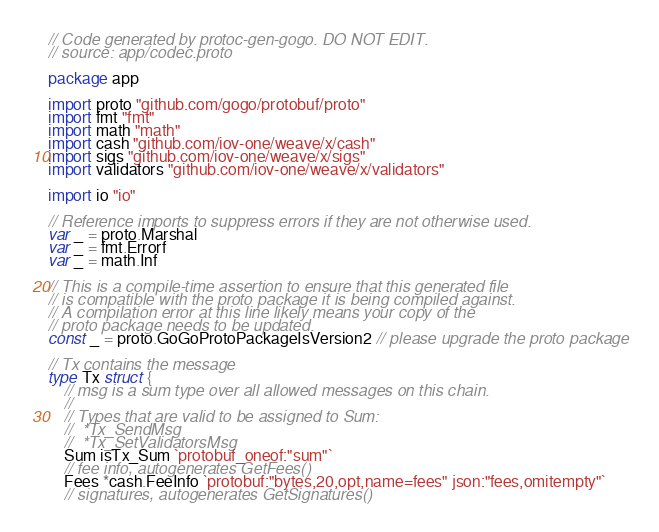Convert code to text. <code><loc_0><loc_0><loc_500><loc_500><_Go_>// Code generated by protoc-gen-gogo. DO NOT EDIT.
// source: app/codec.proto

package app

import proto "github.com/gogo/protobuf/proto"
import fmt "fmt"
import math "math"
import cash "github.com/iov-one/weave/x/cash"
import sigs "github.com/iov-one/weave/x/sigs"
import validators "github.com/iov-one/weave/x/validators"

import io "io"

// Reference imports to suppress errors if they are not otherwise used.
var _ = proto.Marshal
var _ = fmt.Errorf
var _ = math.Inf

// This is a compile-time assertion to ensure that this generated file
// is compatible with the proto package it is being compiled against.
// A compilation error at this line likely means your copy of the
// proto package needs to be updated.
const _ = proto.GoGoProtoPackageIsVersion2 // please upgrade the proto package

// Tx contains the message
type Tx struct {
	// msg is a sum type over all allowed messages on this chain.
	//
	// Types that are valid to be assigned to Sum:
	//	*Tx_SendMsg
	//	*Tx_SetValidatorsMsg
	Sum isTx_Sum `protobuf_oneof:"sum"`
	// fee info, autogenerates GetFees()
	Fees *cash.FeeInfo `protobuf:"bytes,20,opt,name=fees" json:"fees,omitempty"`
	// signatures, autogenerates GetSignatures()</code> 